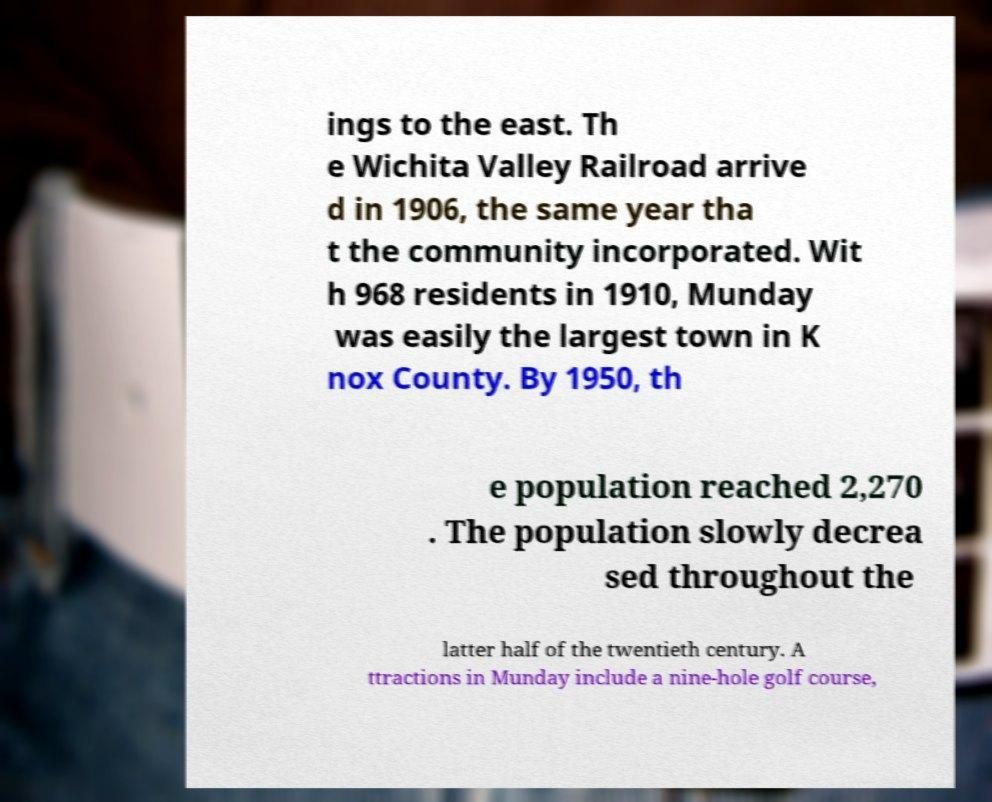Can you read and provide the text displayed in the image?This photo seems to have some interesting text. Can you extract and type it out for me? ings to the east. Th e Wichita Valley Railroad arrive d in 1906, the same year tha t the community incorporated. Wit h 968 residents in 1910, Munday was easily the largest town in K nox County. By 1950, th e population reached 2,270 . The population slowly decrea sed throughout the latter half of the twentieth century. A ttractions in Munday include a nine-hole golf course, 